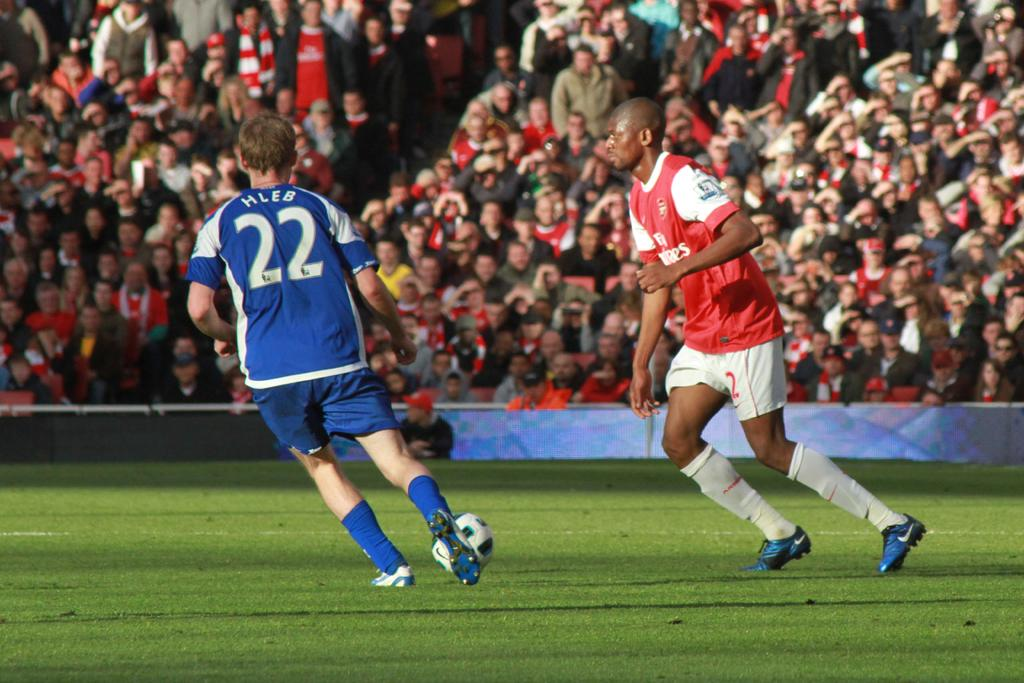<image>
Create a compact narrative representing the image presented. Number 22 kicks the soccer ball in front of his opponent. 